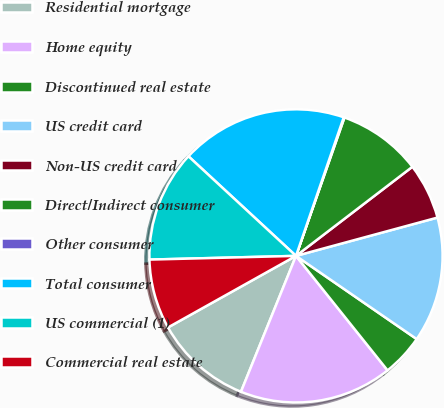<chart> <loc_0><loc_0><loc_500><loc_500><pie_chart><fcel>Residential mortgage<fcel>Home equity<fcel>Discontinued real estate<fcel>US credit card<fcel>Non-US credit card<fcel>Direct/Indirect consumer<fcel>Other consumer<fcel>Total consumer<fcel>US commercial (1)<fcel>Commercial real estate<nl><fcel>10.76%<fcel>16.86%<fcel>4.66%<fcel>13.81%<fcel>6.19%<fcel>9.24%<fcel>0.08%<fcel>18.39%<fcel>12.29%<fcel>7.71%<nl></chart> 